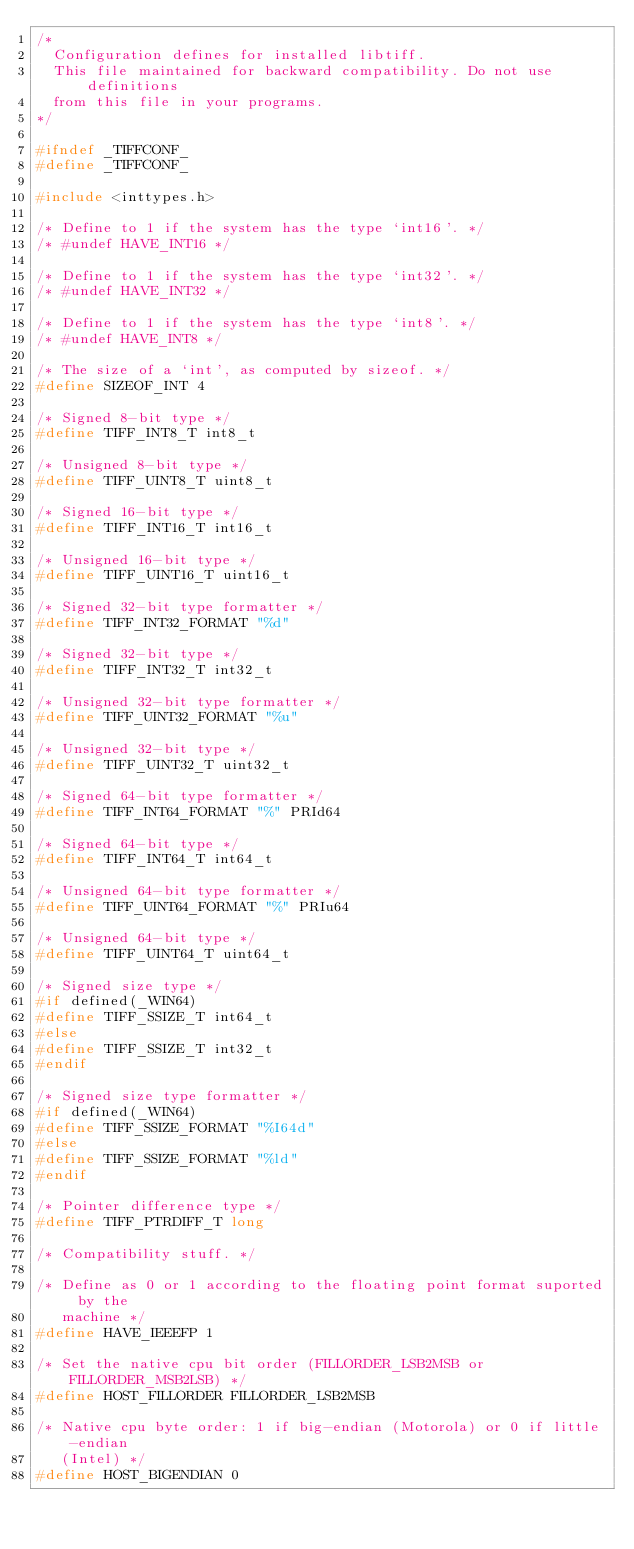Convert code to text. <code><loc_0><loc_0><loc_500><loc_500><_C_>/*
  Configuration defines for installed libtiff.
  This file maintained for backward compatibility. Do not use definitions
  from this file in your programs.
*/

#ifndef _TIFFCONF_
#define _TIFFCONF_

#include <inttypes.h>

/* Define to 1 if the system has the type `int16'. */
/* #undef HAVE_INT16 */

/* Define to 1 if the system has the type `int32'. */
/* #undef HAVE_INT32 */

/* Define to 1 if the system has the type `int8'. */
/* #undef HAVE_INT8 */

/* The size of a `int', as computed by sizeof. */
#define SIZEOF_INT 4

/* Signed 8-bit type */
#define TIFF_INT8_T int8_t

/* Unsigned 8-bit type */
#define TIFF_UINT8_T uint8_t

/* Signed 16-bit type */
#define TIFF_INT16_T int16_t

/* Unsigned 16-bit type */
#define TIFF_UINT16_T uint16_t

/* Signed 32-bit type formatter */
#define TIFF_INT32_FORMAT "%d"

/* Signed 32-bit type */
#define TIFF_INT32_T int32_t

/* Unsigned 32-bit type formatter */
#define TIFF_UINT32_FORMAT "%u"

/* Unsigned 32-bit type */
#define TIFF_UINT32_T uint32_t

/* Signed 64-bit type formatter */
#define TIFF_INT64_FORMAT "%" PRId64

/* Signed 64-bit type */
#define TIFF_INT64_T int64_t

/* Unsigned 64-bit type formatter */
#define TIFF_UINT64_FORMAT "%" PRIu64

/* Unsigned 64-bit type */
#define TIFF_UINT64_T uint64_t

/* Signed size type */
#if defined(_WIN64)
#define TIFF_SSIZE_T int64_t
#else
#define TIFF_SSIZE_T int32_t
#endif

/* Signed size type formatter */
#if defined(_WIN64)
#define TIFF_SSIZE_FORMAT "%I64d"
#else
#define TIFF_SSIZE_FORMAT "%ld"
#endif

/* Pointer difference type */
#define TIFF_PTRDIFF_T long

/* Compatibility stuff. */

/* Define as 0 or 1 according to the floating point format suported by the
   machine */
#define HAVE_IEEEFP 1

/* Set the native cpu bit order (FILLORDER_LSB2MSB or FILLORDER_MSB2LSB) */
#define HOST_FILLORDER FILLORDER_LSB2MSB

/* Native cpu byte order: 1 if big-endian (Motorola) or 0 if little-endian
   (Intel) */
#define HOST_BIGENDIAN 0
</code> 